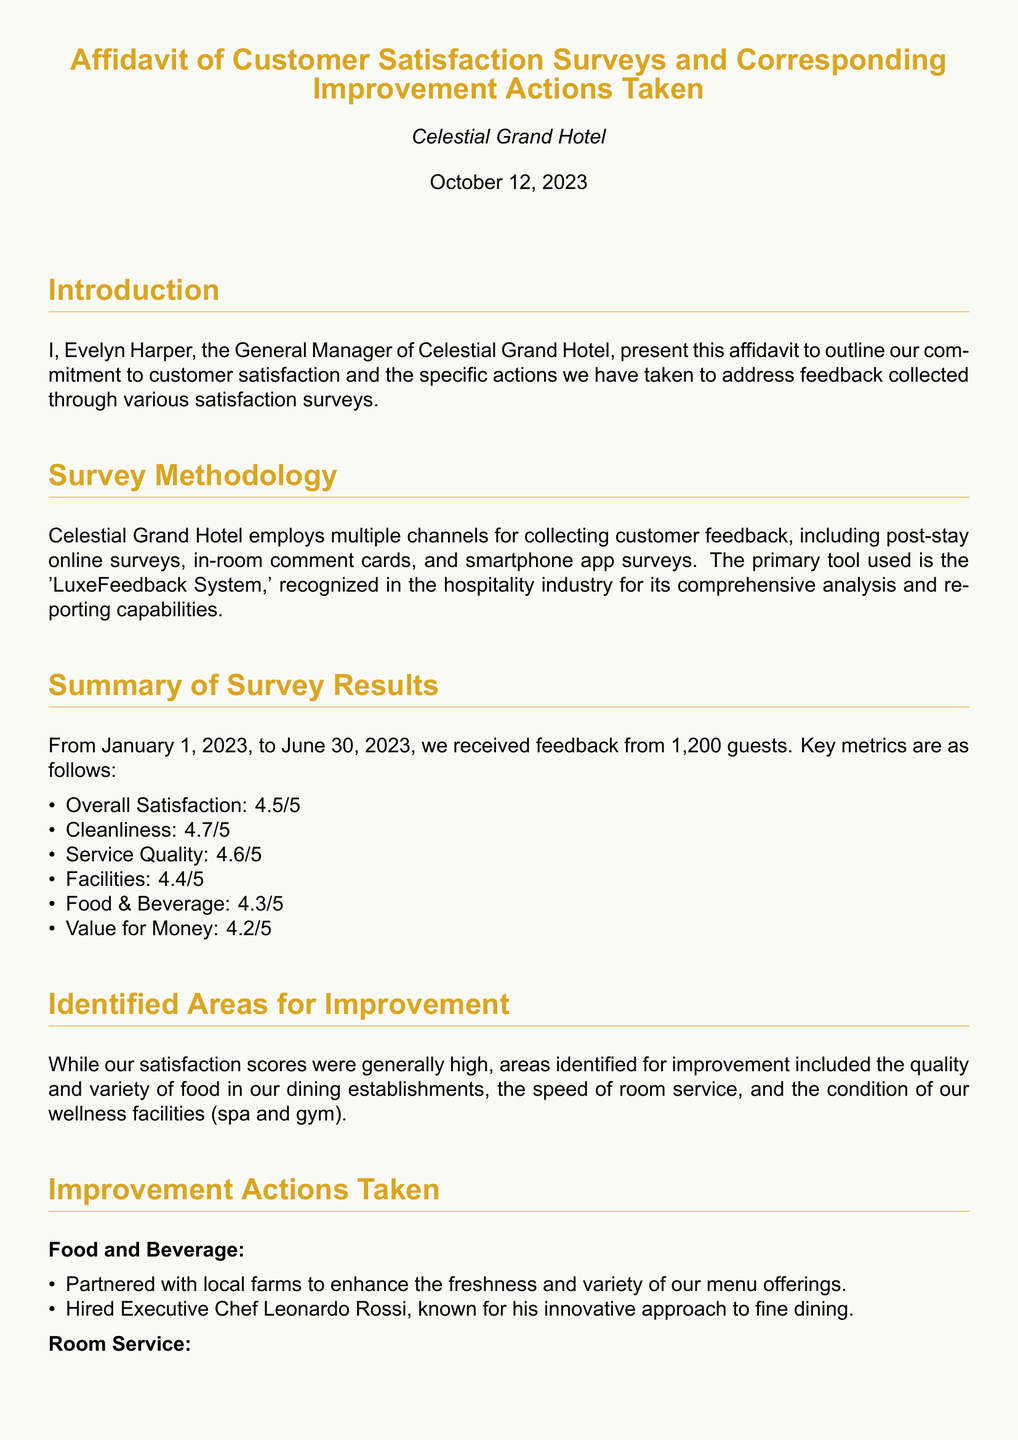What is the overall satisfaction score? The overall satisfaction score is a key metric for customer satisfaction as indicated in the survey results.
Answer: 4.5/5 Who is the General Manager of Celestial Grand Hotel? The General Manager's name is stated in the introduction of the affidavit.
Answer: Evelyn Harper What date was the affidavit signed? The date of the affidavit is important for understanding the timeliness of the information.
Answer: October 12, 2023 What specific area of food improvement was mentioned? The area of improvement regarding food is highlighted in the identified areas for improvement section.
Answer: Quality and variety What is the name of the Executive Chef hired? The name of the new Executive Chef is mentioned in the section detailing improvement actions taken.
Answer: Leonardo Rossi How many guests provided feedback? The total number of guests who provided feedback is cited in the summary of survey results.
Answer: 1,200 What is one improvement action taken for room service? Improvement actions for room service are detailed, and one specific action is given.
Answer: Introduced an express room service menu What kind of new equipment was added to the wellness facilities? This question is designed to identify what specific improvements were made in wellness facilities.
Answer: Therapeutic equipment How did a guest describe the new dining menu? The testimonial provided presents a specific guest's opinion on improvements.
Answer: Fabulous 